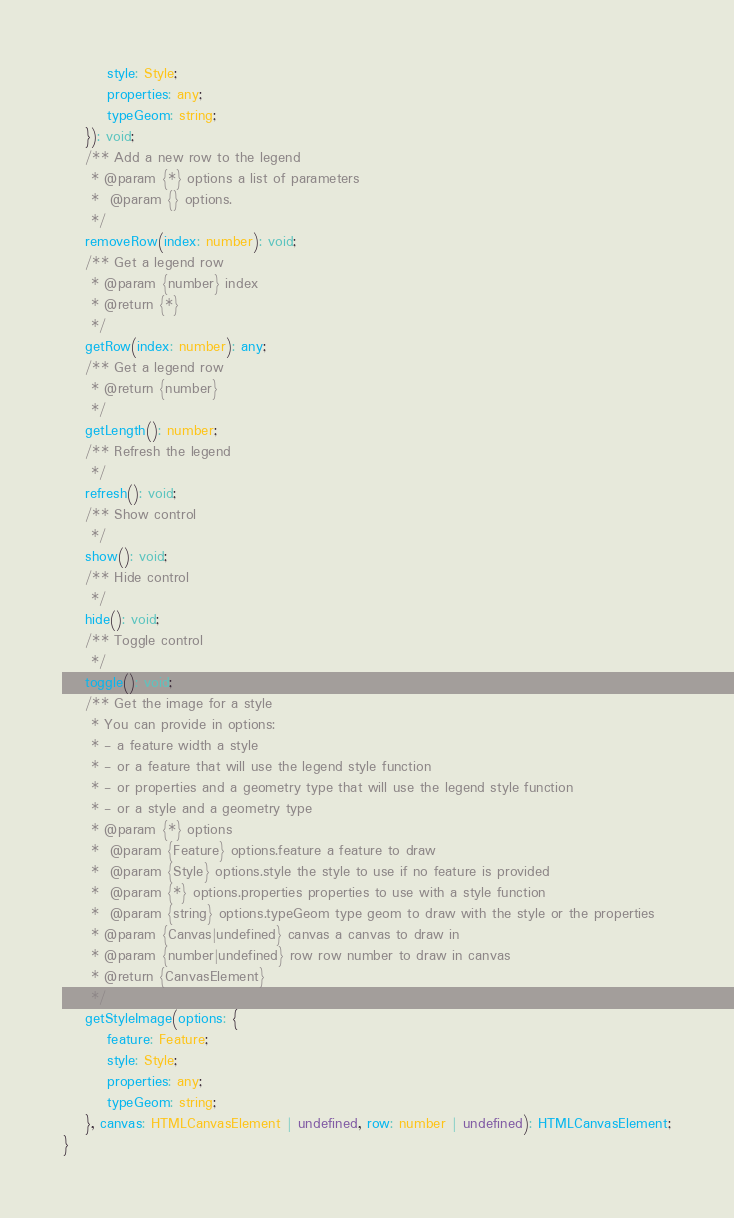Convert code to text. <code><loc_0><loc_0><loc_500><loc_500><_TypeScript_>        style: Style;
        properties: any;
        typeGeom: string;
    }): void;
    /** Add a new row to the legend
     * @param {*} options a list of parameters
     *  @param {} options.
     */
    removeRow(index: number): void;
    /** Get a legend row
     * @param {number} index
     * @return {*}
     */
    getRow(index: number): any;
    /** Get a legend row
     * @return {number}
     */
    getLength(): number;
    /** Refresh the legend
     */
    refresh(): void;
    /** Show control
     */
    show(): void;
    /** Hide control
     */
    hide(): void;
    /** Toggle control
     */
    toggle(): void;
    /** Get the image for a style
     * You can provide in options:
     * - a feature width a style
     * - or a feature that will use the legend style function
     * - or properties and a geometry type that will use the legend style function
     * - or a style and a geometry type
     * @param {*} options
     *  @param {Feature} options.feature a feature to draw
     *  @param {Style} options.style the style to use if no feature is provided
     *  @param {*} options.properties properties to use with a style function
     *  @param {string} options.typeGeom type geom to draw with the style or the properties
     * @param {Canvas|undefined} canvas a canvas to draw in
     * @param {number|undefined} row row number to draw in canvas
     * @return {CanvasElement}
     */
    getStyleImage(options: {
        feature: Feature;
        style: Style;
        properties: any;
        typeGeom: string;
    }, canvas: HTMLCanvasElement | undefined, row: number | undefined): HTMLCanvasElement;
}
</code> 